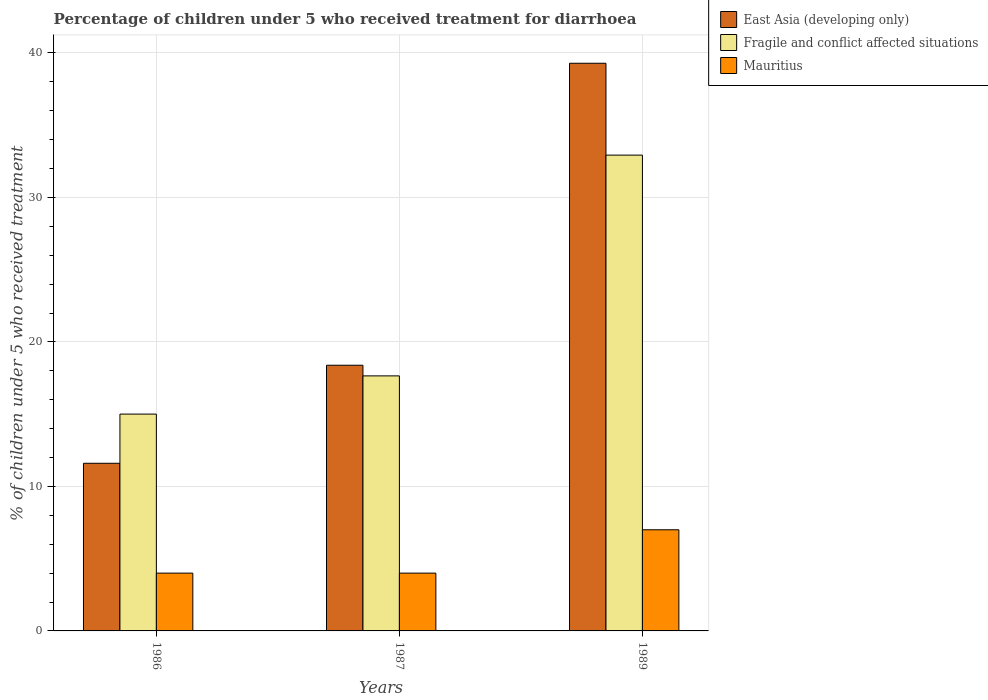Are the number of bars per tick equal to the number of legend labels?
Your answer should be very brief. Yes. How many bars are there on the 1st tick from the left?
Your response must be concise. 3. How many bars are there on the 1st tick from the right?
Provide a short and direct response. 3. What is the label of the 1st group of bars from the left?
Keep it short and to the point. 1986. What is the percentage of children who received treatment for diarrhoea  in Mauritius in 1989?
Your answer should be very brief. 7. Across all years, what is the minimum percentage of children who received treatment for diarrhoea  in East Asia (developing only)?
Your answer should be very brief. 11.6. In which year was the percentage of children who received treatment for diarrhoea  in Mauritius maximum?
Offer a very short reply. 1989. What is the total percentage of children who received treatment for diarrhoea  in Fragile and conflict affected situations in the graph?
Provide a succinct answer. 65.58. What is the difference between the percentage of children who received treatment for diarrhoea  in East Asia (developing only) in 1986 and that in 1987?
Offer a terse response. -6.78. What is the difference between the percentage of children who received treatment for diarrhoea  in Fragile and conflict affected situations in 1986 and the percentage of children who received treatment for diarrhoea  in East Asia (developing only) in 1987?
Ensure brevity in your answer.  -3.38. What is the average percentage of children who received treatment for diarrhoea  in Mauritius per year?
Offer a terse response. 5. In the year 1989, what is the difference between the percentage of children who received treatment for diarrhoea  in Fragile and conflict affected situations and percentage of children who received treatment for diarrhoea  in Mauritius?
Your response must be concise. 25.93. What is the ratio of the percentage of children who received treatment for diarrhoea  in East Asia (developing only) in 1987 to that in 1989?
Offer a terse response. 0.47. Is the percentage of children who received treatment for diarrhoea  in Mauritius in 1986 less than that in 1989?
Your response must be concise. Yes. What is the difference between the highest and the second highest percentage of children who received treatment for diarrhoea  in Fragile and conflict affected situations?
Offer a terse response. 15.28. Is the sum of the percentage of children who received treatment for diarrhoea  in East Asia (developing only) in 1986 and 1987 greater than the maximum percentage of children who received treatment for diarrhoea  in Fragile and conflict affected situations across all years?
Provide a short and direct response. No. What does the 2nd bar from the left in 1986 represents?
Your answer should be very brief. Fragile and conflict affected situations. What does the 3rd bar from the right in 1989 represents?
Ensure brevity in your answer.  East Asia (developing only). Is it the case that in every year, the sum of the percentage of children who received treatment for diarrhoea  in Mauritius and percentage of children who received treatment for diarrhoea  in East Asia (developing only) is greater than the percentage of children who received treatment for diarrhoea  in Fragile and conflict affected situations?
Your response must be concise. Yes. How many bars are there?
Your answer should be very brief. 9. Are all the bars in the graph horizontal?
Ensure brevity in your answer.  No. What is the difference between two consecutive major ticks on the Y-axis?
Your response must be concise. 10. Are the values on the major ticks of Y-axis written in scientific E-notation?
Your answer should be compact. No. Does the graph contain grids?
Your answer should be very brief. Yes. Where does the legend appear in the graph?
Your response must be concise. Top right. What is the title of the graph?
Make the answer very short. Percentage of children under 5 who received treatment for diarrhoea. What is the label or title of the X-axis?
Your answer should be very brief. Years. What is the label or title of the Y-axis?
Keep it short and to the point. % of children under 5 who received treatment. What is the % of children under 5 who received treatment in East Asia (developing only) in 1986?
Provide a short and direct response. 11.6. What is the % of children under 5 who received treatment of Fragile and conflict affected situations in 1986?
Your response must be concise. 15.01. What is the % of children under 5 who received treatment of East Asia (developing only) in 1987?
Make the answer very short. 18.39. What is the % of children under 5 who received treatment of Fragile and conflict affected situations in 1987?
Give a very brief answer. 17.65. What is the % of children under 5 who received treatment of Mauritius in 1987?
Give a very brief answer. 4. What is the % of children under 5 who received treatment of East Asia (developing only) in 1989?
Offer a very short reply. 39.29. What is the % of children under 5 who received treatment in Fragile and conflict affected situations in 1989?
Make the answer very short. 32.93. Across all years, what is the maximum % of children under 5 who received treatment in East Asia (developing only)?
Make the answer very short. 39.29. Across all years, what is the maximum % of children under 5 who received treatment of Fragile and conflict affected situations?
Your answer should be very brief. 32.93. Across all years, what is the maximum % of children under 5 who received treatment in Mauritius?
Offer a terse response. 7. Across all years, what is the minimum % of children under 5 who received treatment in East Asia (developing only)?
Your answer should be compact. 11.6. Across all years, what is the minimum % of children under 5 who received treatment in Fragile and conflict affected situations?
Your answer should be compact. 15.01. Across all years, what is the minimum % of children under 5 who received treatment in Mauritius?
Offer a very short reply. 4. What is the total % of children under 5 who received treatment in East Asia (developing only) in the graph?
Your response must be concise. 69.27. What is the total % of children under 5 who received treatment in Fragile and conflict affected situations in the graph?
Your answer should be compact. 65.58. What is the difference between the % of children under 5 who received treatment in East Asia (developing only) in 1986 and that in 1987?
Your answer should be compact. -6.78. What is the difference between the % of children under 5 who received treatment of Fragile and conflict affected situations in 1986 and that in 1987?
Offer a very short reply. -2.64. What is the difference between the % of children under 5 who received treatment of East Asia (developing only) in 1986 and that in 1989?
Provide a short and direct response. -27.68. What is the difference between the % of children under 5 who received treatment in Fragile and conflict affected situations in 1986 and that in 1989?
Provide a short and direct response. -17.92. What is the difference between the % of children under 5 who received treatment of Mauritius in 1986 and that in 1989?
Offer a very short reply. -3. What is the difference between the % of children under 5 who received treatment of East Asia (developing only) in 1987 and that in 1989?
Your answer should be very brief. -20.9. What is the difference between the % of children under 5 who received treatment of Fragile and conflict affected situations in 1987 and that in 1989?
Offer a terse response. -15.28. What is the difference between the % of children under 5 who received treatment of East Asia (developing only) in 1986 and the % of children under 5 who received treatment of Fragile and conflict affected situations in 1987?
Offer a terse response. -6.05. What is the difference between the % of children under 5 who received treatment of East Asia (developing only) in 1986 and the % of children under 5 who received treatment of Mauritius in 1987?
Give a very brief answer. 7.6. What is the difference between the % of children under 5 who received treatment in Fragile and conflict affected situations in 1986 and the % of children under 5 who received treatment in Mauritius in 1987?
Keep it short and to the point. 11.01. What is the difference between the % of children under 5 who received treatment in East Asia (developing only) in 1986 and the % of children under 5 who received treatment in Fragile and conflict affected situations in 1989?
Your answer should be compact. -21.33. What is the difference between the % of children under 5 who received treatment in East Asia (developing only) in 1986 and the % of children under 5 who received treatment in Mauritius in 1989?
Your answer should be compact. 4.6. What is the difference between the % of children under 5 who received treatment in Fragile and conflict affected situations in 1986 and the % of children under 5 who received treatment in Mauritius in 1989?
Your response must be concise. 8.01. What is the difference between the % of children under 5 who received treatment in East Asia (developing only) in 1987 and the % of children under 5 who received treatment in Fragile and conflict affected situations in 1989?
Offer a terse response. -14.54. What is the difference between the % of children under 5 who received treatment of East Asia (developing only) in 1987 and the % of children under 5 who received treatment of Mauritius in 1989?
Provide a succinct answer. 11.39. What is the difference between the % of children under 5 who received treatment of Fragile and conflict affected situations in 1987 and the % of children under 5 who received treatment of Mauritius in 1989?
Provide a succinct answer. 10.65. What is the average % of children under 5 who received treatment in East Asia (developing only) per year?
Give a very brief answer. 23.09. What is the average % of children under 5 who received treatment of Fragile and conflict affected situations per year?
Your response must be concise. 21.86. What is the average % of children under 5 who received treatment of Mauritius per year?
Provide a short and direct response. 5. In the year 1986, what is the difference between the % of children under 5 who received treatment in East Asia (developing only) and % of children under 5 who received treatment in Fragile and conflict affected situations?
Offer a terse response. -3.4. In the year 1986, what is the difference between the % of children under 5 who received treatment in East Asia (developing only) and % of children under 5 who received treatment in Mauritius?
Your answer should be compact. 7.6. In the year 1986, what is the difference between the % of children under 5 who received treatment in Fragile and conflict affected situations and % of children under 5 who received treatment in Mauritius?
Your answer should be very brief. 11.01. In the year 1987, what is the difference between the % of children under 5 who received treatment of East Asia (developing only) and % of children under 5 who received treatment of Fragile and conflict affected situations?
Your answer should be compact. 0.74. In the year 1987, what is the difference between the % of children under 5 who received treatment in East Asia (developing only) and % of children under 5 who received treatment in Mauritius?
Provide a short and direct response. 14.39. In the year 1987, what is the difference between the % of children under 5 who received treatment in Fragile and conflict affected situations and % of children under 5 who received treatment in Mauritius?
Give a very brief answer. 13.65. In the year 1989, what is the difference between the % of children under 5 who received treatment in East Asia (developing only) and % of children under 5 who received treatment in Fragile and conflict affected situations?
Offer a terse response. 6.36. In the year 1989, what is the difference between the % of children under 5 who received treatment of East Asia (developing only) and % of children under 5 who received treatment of Mauritius?
Make the answer very short. 32.29. In the year 1989, what is the difference between the % of children under 5 who received treatment of Fragile and conflict affected situations and % of children under 5 who received treatment of Mauritius?
Ensure brevity in your answer.  25.93. What is the ratio of the % of children under 5 who received treatment in East Asia (developing only) in 1986 to that in 1987?
Give a very brief answer. 0.63. What is the ratio of the % of children under 5 who received treatment of Fragile and conflict affected situations in 1986 to that in 1987?
Your answer should be very brief. 0.85. What is the ratio of the % of children under 5 who received treatment of East Asia (developing only) in 1986 to that in 1989?
Provide a short and direct response. 0.3. What is the ratio of the % of children under 5 who received treatment in Fragile and conflict affected situations in 1986 to that in 1989?
Provide a succinct answer. 0.46. What is the ratio of the % of children under 5 who received treatment in East Asia (developing only) in 1987 to that in 1989?
Your response must be concise. 0.47. What is the ratio of the % of children under 5 who received treatment of Fragile and conflict affected situations in 1987 to that in 1989?
Provide a succinct answer. 0.54. What is the difference between the highest and the second highest % of children under 5 who received treatment of East Asia (developing only)?
Offer a terse response. 20.9. What is the difference between the highest and the second highest % of children under 5 who received treatment of Fragile and conflict affected situations?
Provide a short and direct response. 15.28. What is the difference between the highest and the second highest % of children under 5 who received treatment of Mauritius?
Your answer should be compact. 3. What is the difference between the highest and the lowest % of children under 5 who received treatment of East Asia (developing only)?
Provide a short and direct response. 27.68. What is the difference between the highest and the lowest % of children under 5 who received treatment of Fragile and conflict affected situations?
Provide a short and direct response. 17.92. 